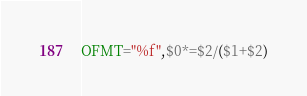Convert code to text. <code><loc_0><loc_0><loc_500><loc_500><_Awk_>OFMT="%f",$0*=$2/($1+$2)</code> 